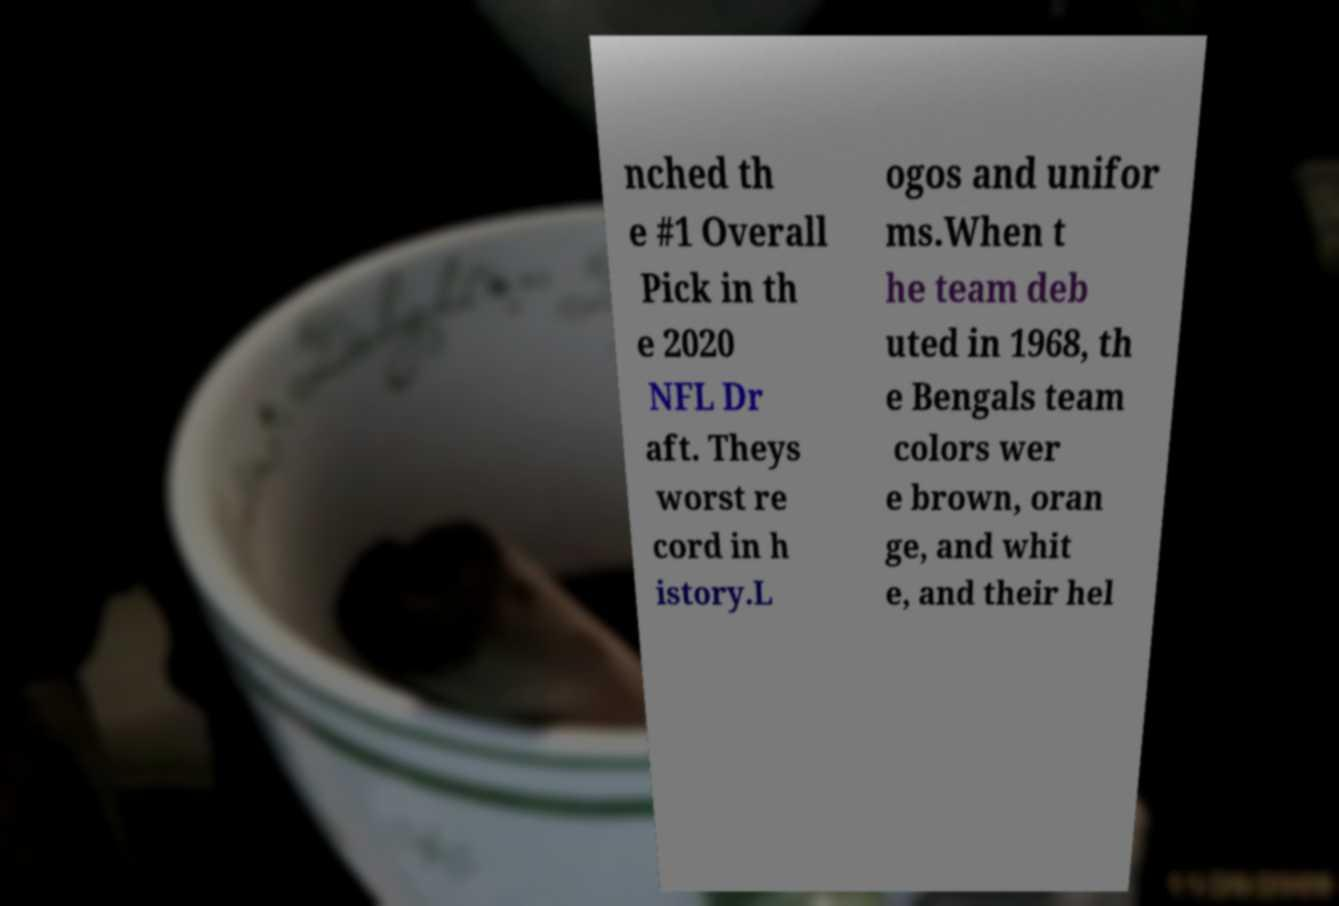Could you assist in decoding the text presented in this image and type it out clearly? nched th e #1 Overall Pick in th e 2020 NFL Dr aft. Theys worst re cord in h istory.L ogos and unifor ms.When t he team deb uted in 1968, th e Bengals team colors wer e brown, oran ge, and whit e, and their hel 